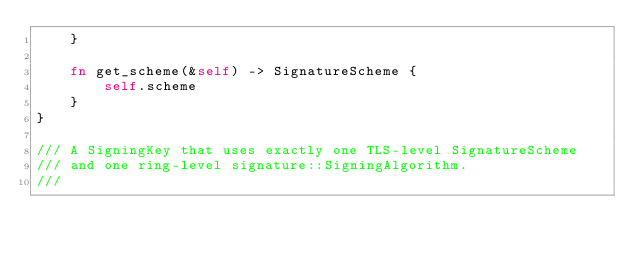<code> <loc_0><loc_0><loc_500><loc_500><_Rust_>    }

    fn get_scheme(&self) -> SignatureScheme {
        self.scheme
    }
}

/// A SigningKey that uses exactly one TLS-level SignatureScheme
/// and one ring-level signature::SigningAlgorithm.
///</code> 